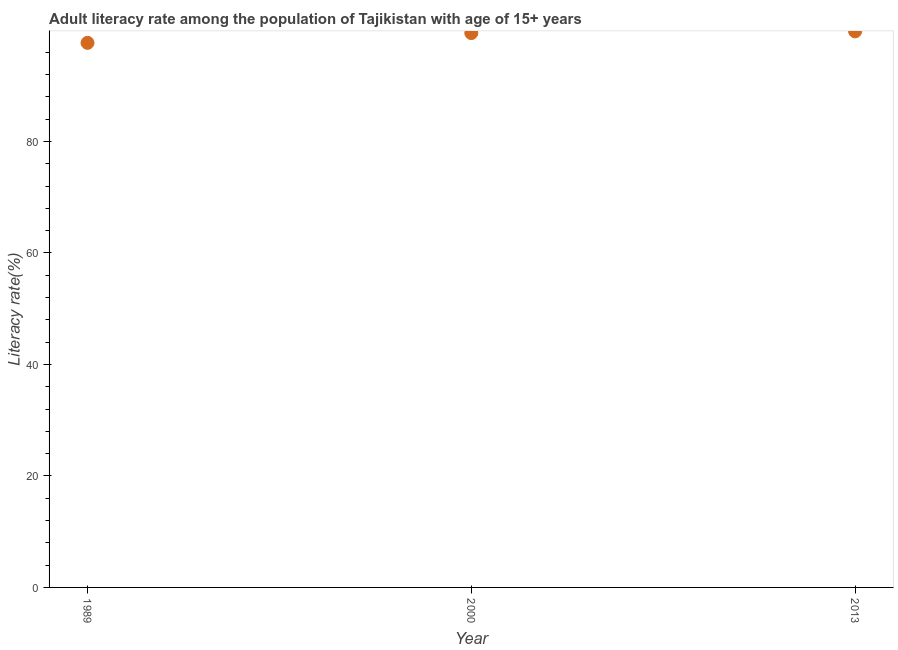What is the adult literacy rate in 2013?
Keep it short and to the point. 99.75. Across all years, what is the maximum adult literacy rate?
Make the answer very short. 99.75. Across all years, what is the minimum adult literacy rate?
Provide a succinct answer. 97.69. What is the sum of the adult literacy rate?
Your answer should be compact. 296.9. What is the difference between the adult literacy rate in 1989 and 2013?
Offer a very short reply. -2.06. What is the average adult literacy rate per year?
Your response must be concise. 98.97. What is the median adult literacy rate?
Provide a succinct answer. 99.45. In how many years, is the adult literacy rate greater than 56 %?
Keep it short and to the point. 3. What is the ratio of the adult literacy rate in 1989 to that in 2013?
Make the answer very short. 0.98. Is the adult literacy rate in 2000 less than that in 2013?
Make the answer very short. Yes. Is the difference between the adult literacy rate in 2000 and 2013 greater than the difference between any two years?
Provide a succinct answer. No. What is the difference between the highest and the second highest adult literacy rate?
Your answer should be compact. 0.3. Is the sum of the adult literacy rate in 2000 and 2013 greater than the maximum adult literacy rate across all years?
Offer a terse response. Yes. What is the difference between the highest and the lowest adult literacy rate?
Make the answer very short. 2.06. In how many years, is the adult literacy rate greater than the average adult literacy rate taken over all years?
Your answer should be very brief. 2. What is the difference between two consecutive major ticks on the Y-axis?
Offer a terse response. 20. Are the values on the major ticks of Y-axis written in scientific E-notation?
Keep it short and to the point. No. What is the title of the graph?
Keep it short and to the point. Adult literacy rate among the population of Tajikistan with age of 15+ years. What is the label or title of the Y-axis?
Ensure brevity in your answer.  Literacy rate(%). What is the Literacy rate(%) in 1989?
Make the answer very short. 97.69. What is the Literacy rate(%) in 2000?
Keep it short and to the point. 99.45. What is the Literacy rate(%) in 2013?
Offer a terse response. 99.75. What is the difference between the Literacy rate(%) in 1989 and 2000?
Your answer should be compact. -1.76. What is the difference between the Literacy rate(%) in 1989 and 2013?
Your response must be concise. -2.06. What is the difference between the Literacy rate(%) in 2000 and 2013?
Give a very brief answer. -0.3. What is the ratio of the Literacy rate(%) in 1989 to that in 2013?
Your response must be concise. 0.98. What is the ratio of the Literacy rate(%) in 2000 to that in 2013?
Offer a very short reply. 1. 